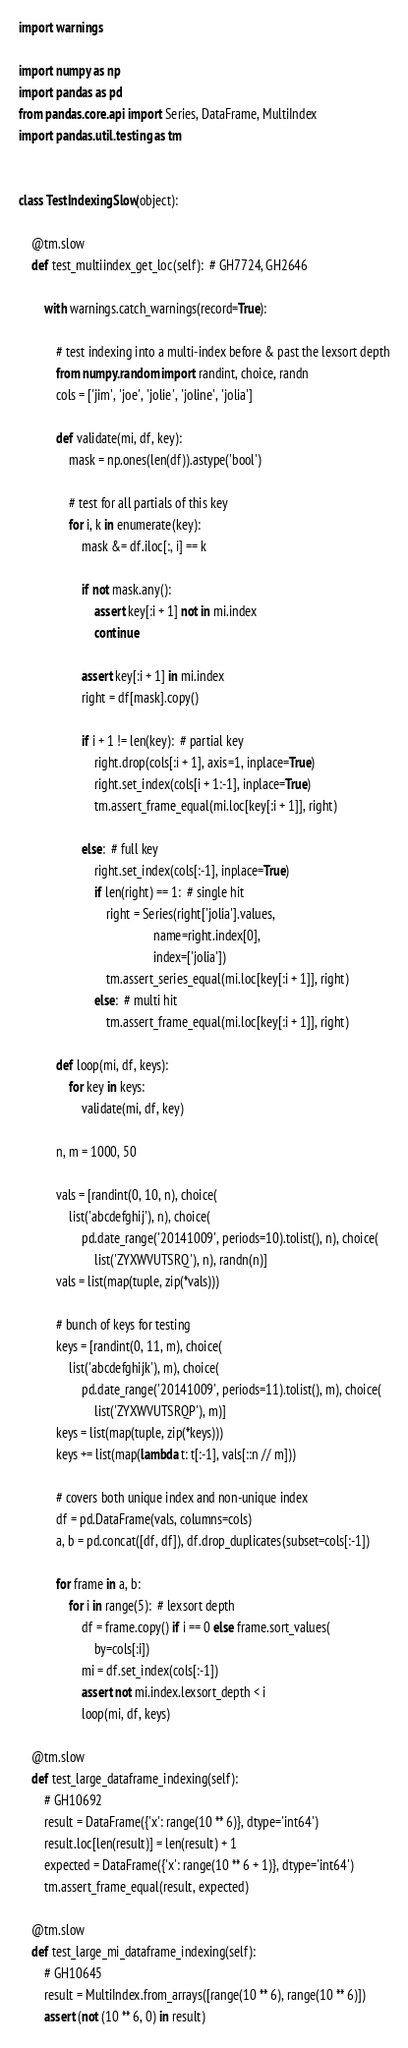<code> <loc_0><loc_0><loc_500><loc_500><_Python_>import warnings

import numpy as np
import pandas as pd
from pandas.core.api import Series, DataFrame, MultiIndex
import pandas.util.testing as tm


class TestIndexingSlow(object):

    @tm.slow
    def test_multiindex_get_loc(self):  # GH7724, GH2646

        with warnings.catch_warnings(record=True):

            # test indexing into a multi-index before & past the lexsort depth
            from numpy.random import randint, choice, randn
            cols = ['jim', 'joe', 'jolie', 'joline', 'jolia']

            def validate(mi, df, key):
                mask = np.ones(len(df)).astype('bool')

                # test for all partials of this key
                for i, k in enumerate(key):
                    mask &= df.iloc[:, i] == k

                    if not mask.any():
                        assert key[:i + 1] not in mi.index
                        continue

                    assert key[:i + 1] in mi.index
                    right = df[mask].copy()

                    if i + 1 != len(key):  # partial key
                        right.drop(cols[:i + 1], axis=1, inplace=True)
                        right.set_index(cols[i + 1:-1], inplace=True)
                        tm.assert_frame_equal(mi.loc[key[:i + 1]], right)

                    else:  # full key
                        right.set_index(cols[:-1], inplace=True)
                        if len(right) == 1:  # single hit
                            right = Series(right['jolia'].values,
                                           name=right.index[0],
                                           index=['jolia'])
                            tm.assert_series_equal(mi.loc[key[:i + 1]], right)
                        else:  # multi hit
                            tm.assert_frame_equal(mi.loc[key[:i + 1]], right)

            def loop(mi, df, keys):
                for key in keys:
                    validate(mi, df, key)

            n, m = 1000, 50

            vals = [randint(0, 10, n), choice(
                list('abcdefghij'), n), choice(
                    pd.date_range('20141009', periods=10).tolist(), n), choice(
                        list('ZYXWVUTSRQ'), n), randn(n)]
            vals = list(map(tuple, zip(*vals)))

            # bunch of keys for testing
            keys = [randint(0, 11, m), choice(
                list('abcdefghijk'), m), choice(
                    pd.date_range('20141009', periods=11).tolist(), m), choice(
                        list('ZYXWVUTSRQP'), m)]
            keys = list(map(tuple, zip(*keys)))
            keys += list(map(lambda t: t[:-1], vals[::n // m]))

            # covers both unique index and non-unique index
            df = pd.DataFrame(vals, columns=cols)
            a, b = pd.concat([df, df]), df.drop_duplicates(subset=cols[:-1])

            for frame in a, b:
                for i in range(5):  # lexsort depth
                    df = frame.copy() if i == 0 else frame.sort_values(
                        by=cols[:i])
                    mi = df.set_index(cols[:-1])
                    assert not mi.index.lexsort_depth < i
                    loop(mi, df, keys)

    @tm.slow
    def test_large_dataframe_indexing(self):
        # GH10692
        result = DataFrame({'x': range(10 ** 6)}, dtype='int64')
        result.loc[len(result)] = len(result) + 1
        expected = DataFrame({'x': range(10 ** 6 + 1)}, dtype='int64')
        tm.assert_frame_equal(result, expected)

    @tm.slow
    def test_large_mi_dataframe_indexing(self):
        # GH10645
        result = MultiIndex.from_arrays([range(10 ** 6), range(10 ** 6)])
        assert (not (10 ** 6, 0) in result)
</code> 